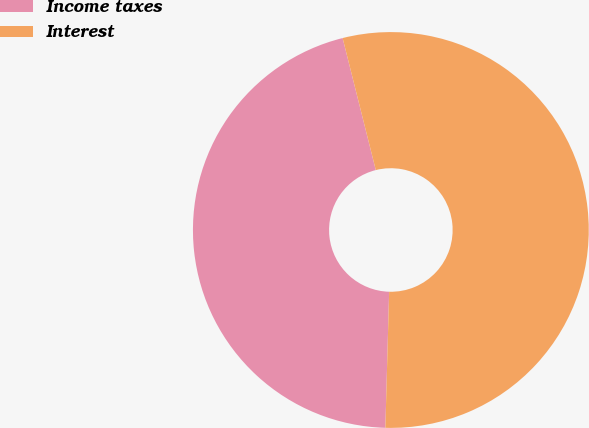Convert chart. <chart><loc_0><loc_0><loc_500><loc_500><pie_chart><fcel>Income taxes<fcel>Interest<nl><fcel>45.64%<fcel>54.36%<nl></chart> 